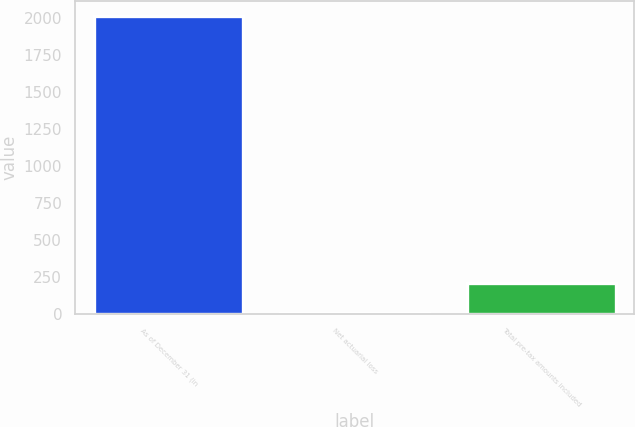Convert chart to OTSL. <chart><loc_0><loc_0><loc_500><loc_500><bar_chart><fcel>As of December 31 (in<fcel>Net actuarial loss<fcel>Total pre-tax amounts included<nl><fcel>2015<fcel>4.2<fcel>205.28<nl></chart> 